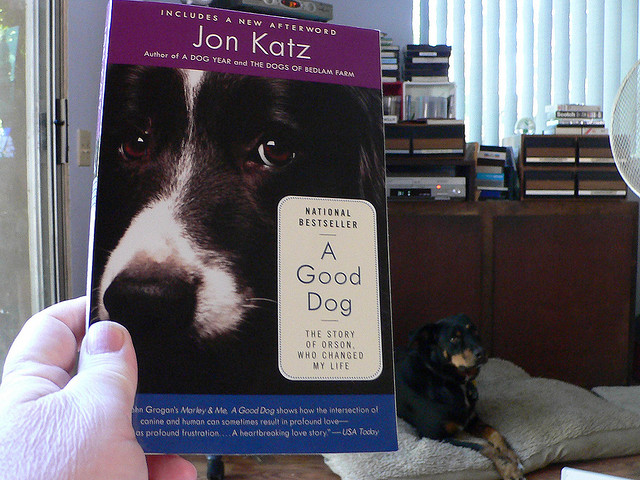How does the image of the dog on the book cover contrast with the dog on the couch? The dog on the book cover is featured in a close-up, displaying a serious or introspective look, focusing the viewer's attention on the dog's eyes and facial expression. In contrast, the live dog on the couch appears relaxed, content, and in a state of rest, showcasing a different mood and context. 